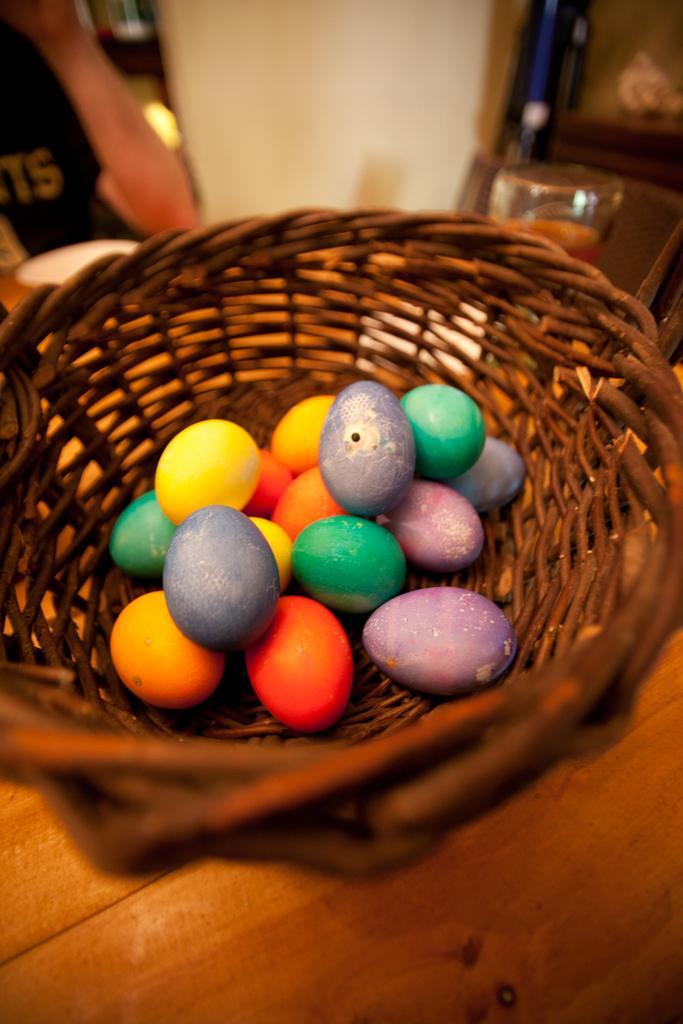Can you describe this image briefly? The picture consists of a basket, in the basket there are eggs. At the top it is blurred. 